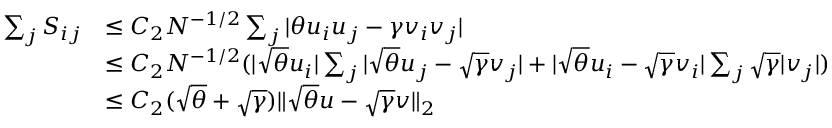<formula> <loc_0><loc_0><loc_500><loc_500>\begin{array} { r l } { \sum _ { j } S _ { i j } } & { \leq C _ { 2 } N ^ { - 1 / 2 } \sum _ { j } | \theta u _ { i } u _ { j } - \gamma v _ { i } v _ { j } | } \\ & { \leq C _ { 2 } N ^ { - 1 / 2 } ( | \sqrt { \theta } u _ { i } | \sum _ { j } | \sqrt { \theta } u _ { j } - \sqrt { \gamma } v _ { j } | + | \sqrt { \theta } u _ { i } - \sqrt { \gamma } v _ { i } | \sum _ { j } \sqrt { \gamma } | v _ { j } | ) } \\ & { \leq C _ { 2 } ( \sqrt { \theta } + \sqrt { \gamma } ) \| \sqrt { \theta } u - \sqrt { \gamma } v \| _ { 2 } } \end{array}</formula> 